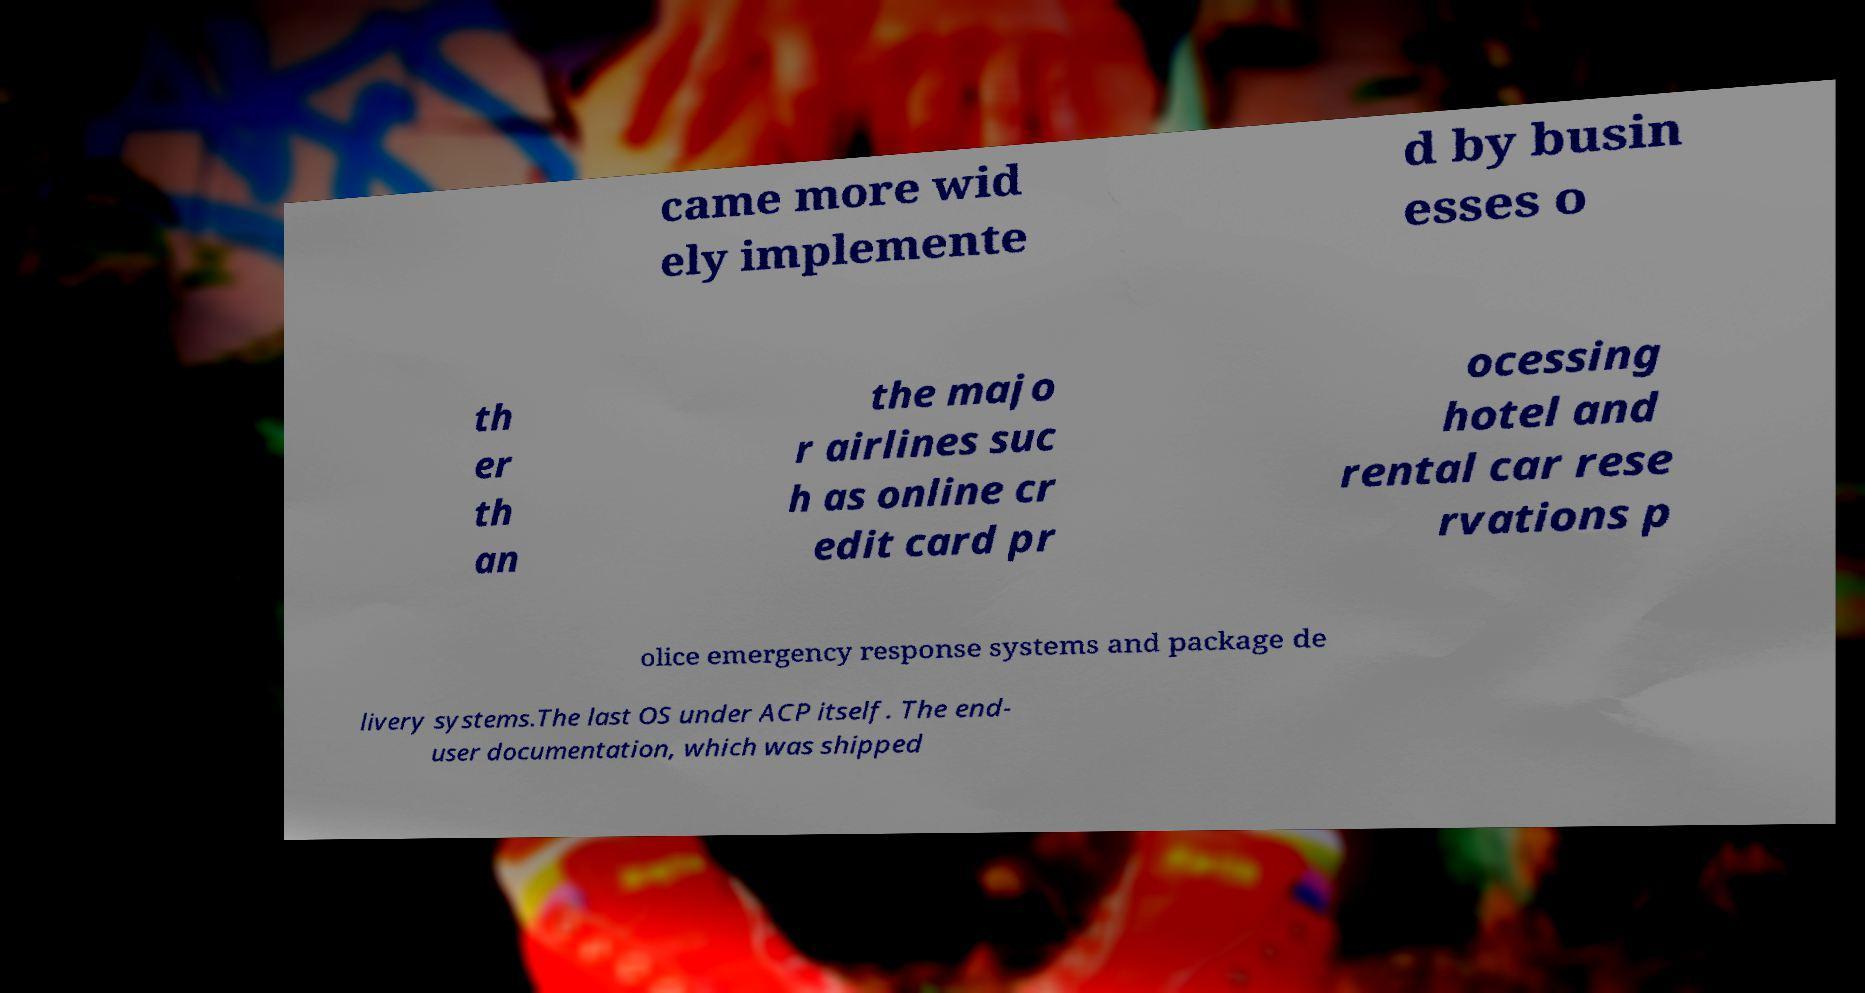Can you accurately transcribe the text from the provided image for me? came more wid ely implemente d by busin esses o th er th an the majo r airlines suc h as online cr edit card pr ocessing hotel and rental car rese rvations p olice emergency response systems and package de livery systems.The last OS under ACP itself. The end- user documentation, which was shipped 